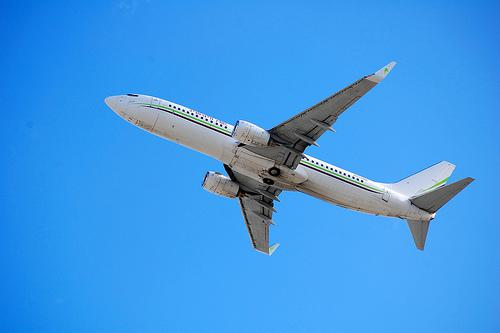How many unicorns are there in the image? There are no unicorns in the image; it is a photograph of a plane flying against a clear blue sky. 